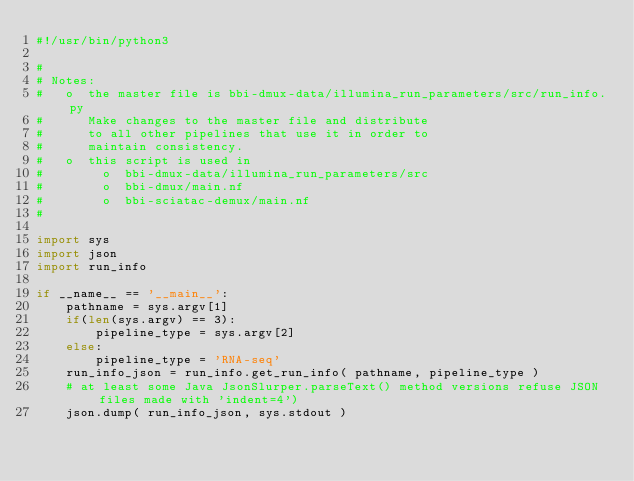<code> <loc_0><loc_0><loc_500><loc_500><_Python_>#!/usr/bin/python3

#
# Notes:
#   o  the master file is bbi-dmux-data/illumina_run_parameters/src/run_info.py
#      Make changes to the master file and distribute
#      to all other pipelines that use it in order to
#      maintain consistency.
#   o  this script is used in
#        o  bbi-dmux-data/illumina_run_parameters/src
#        o  bbi-dmux/main.nf
#        o  bbi-sciatac-demux/main.nf
#

import sys
import json
import run_info

if __name__ == '__main__':
    pathname = sys.argv[1]
    if(len(sys.argv) == 3):
        pipeline_type = sys.argv[2]
    else:
        pipeline_type = 'RNA-seq'
    run_info_json = run_info.get_run_info( pathname, pipeline_type )
    # at least some Java JsonSlurper.parseText() method versions refuse JSON files made with 'indent=4')
    json.dump( run_info_json, sys.stdout )
</code> 